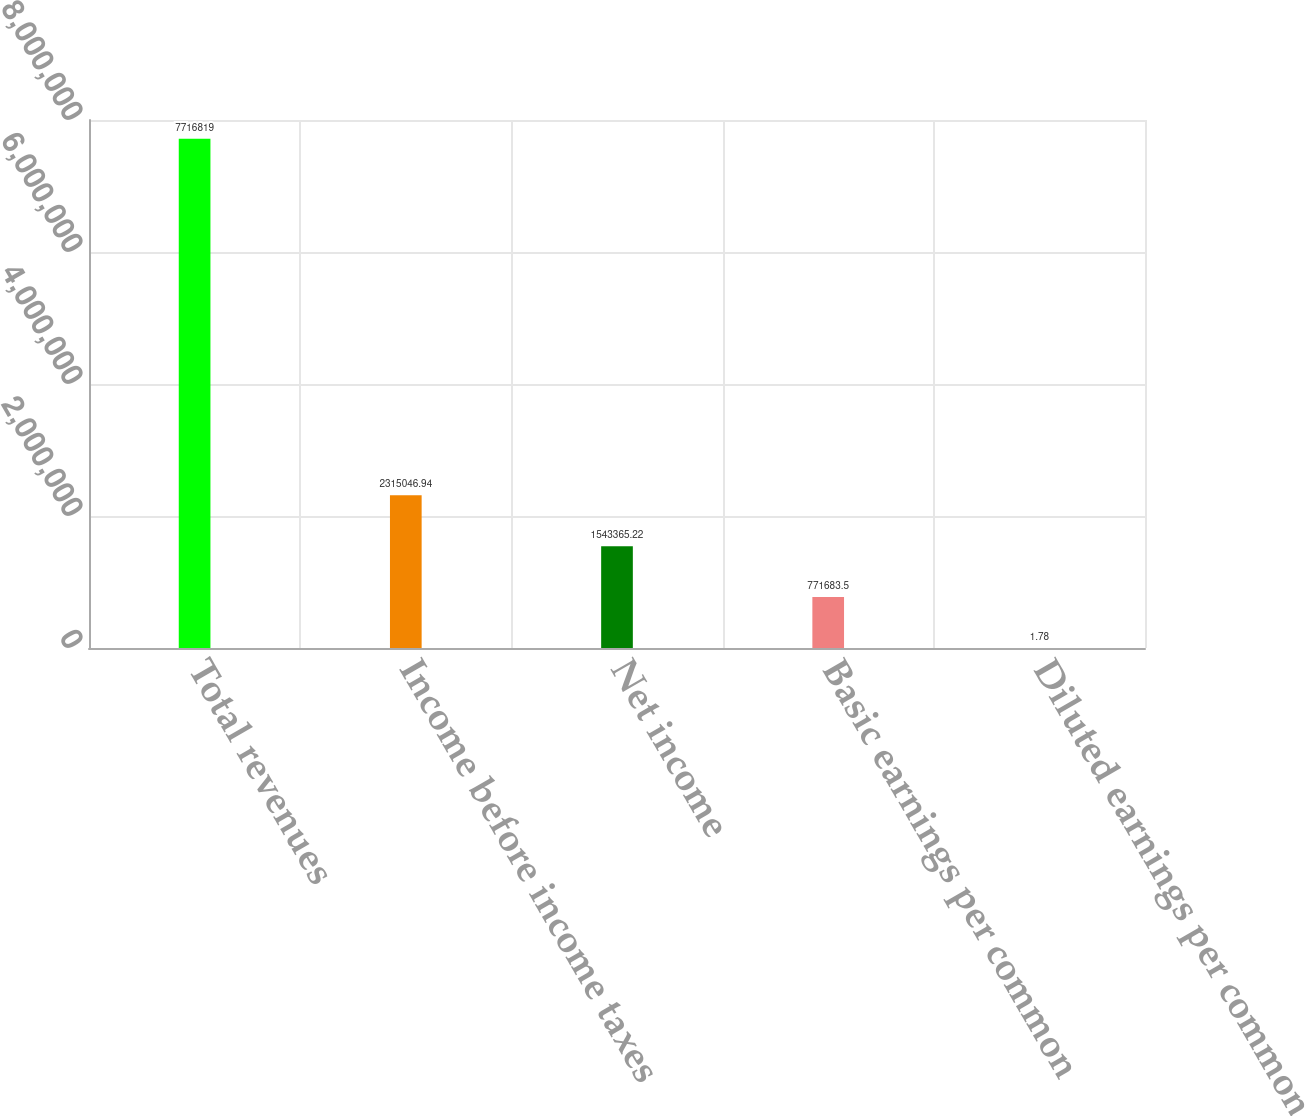Convert chart. <chart><loc_0><loc_0><loc_500><loc_500><bar_chart><fcel>Total revenues<fcel>Income before income taxes<fcel>Net income<fcel>Basic earnings per common<fcel>Diluted earnings per common<nl><fcel>7.71682e+06<fcel>2.31505e+06<fcel>1.54337e+06<fcel>771684<fcel>1.78<nl></chart> 